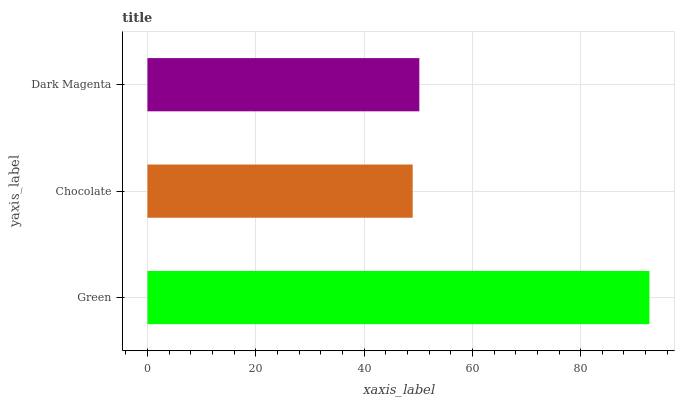Is Chocolate the minimum?
Answer yes or no. Yes. Is Green the maximum?
Answer yes or no. Yes. Is Dark Magenta the minimum?
Answer yes or no. No. Is Dark Magenta the maximum?
Answer yes or no. No. Is Dark Magenta greater than Chocolate?
Answer yes or no. Yes. Is Chocolate less than Dark Magenta?
Answer yes or no. Yes. Is Chocolate greater than Dark Magenta?
Answer yes or no. No. Is Dark Magenta less than Chocolate?
Answer yes or no. No. Is Dark Magenta the high median?
Answer yes or no. Yes. Is Dark Magenta the low median?
Answer yes or no. Yes. Is Chocolate the high median?
Answer yes or no. No. Is Green the low median?
Answer yes or no. No. 